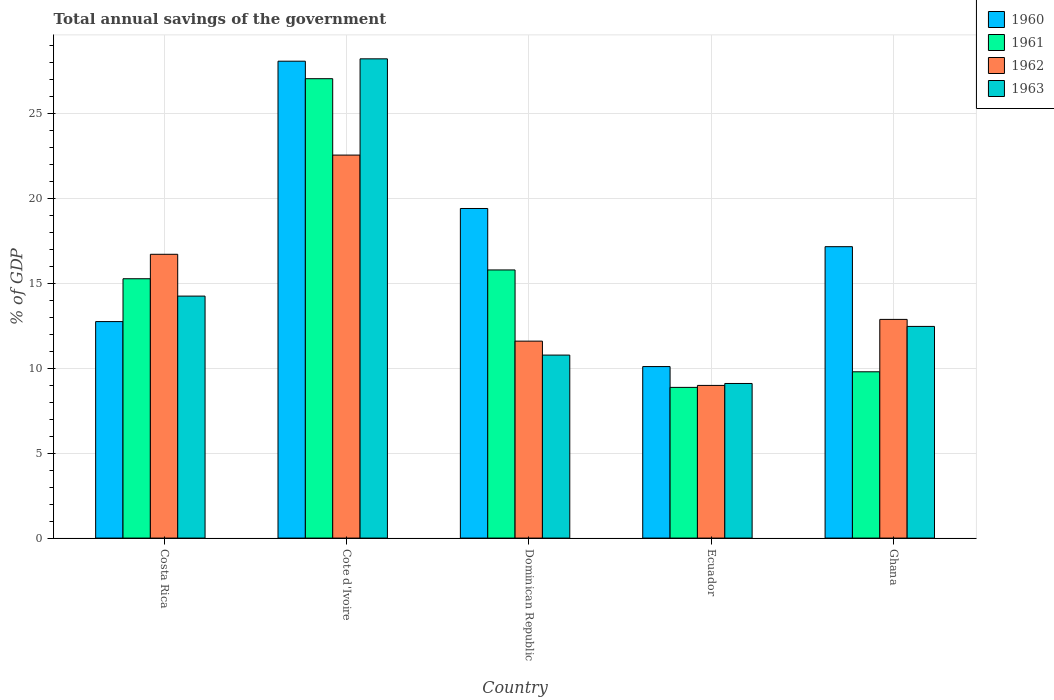How many different coloured bars are there?
Keep it short and to the point. 4. How many groups of bars are there?
Your answer should be very brief. 5. Are the number of bars per tick equal to the number of legend labels?
Ensure brevity in your answer.  Yes. Are the number of bars on each tick of the X-axis equal?
Give a very brief answer. Yes. How many bars are there on the 4th tick from the left?
Provide a succinct answer. 4. What is the total annual savings of the government in 1960 in Cote d'Ivoire?
Keep it short and to the point. 28.06. Across all countries, what is the maximum total annual savings of the government in 1963?
Ensure brevity in your answer.  28.2. Across all countries, what is the minimum total annual savings of the government in 1960?
Offer a very short reply. 10.09. In which country was the total annual savings of the government in 1961 maximum?
Provide a short and direct response. Cote d'Ivoire. In which country was the total annual savings of the government in 1963 minimum?
Give a very brief answer. Ecuador. What is the total total annual savings of the government in 1963 in the graph?
Offer a terse response. 74.76. What is the difference between the total annual savings of the government in 1960 in Cote d'Ivoire and that in Ecuador?
Provide a succinct answer. 17.97. What is the difference between the total annual savings of the government in 1962 in Costa Rica and the total annual savings of the government in 1963 in Ecuador?
Your response must be concise. 7.6. What is the average total annual savings of the government in 1960 per country?
Keep it short and to the point. 17.49. What is the difference between the total annual savings of the government of/in 1961 and total annual savings of the government of/in 1963 in Cote d'Ivoire?
Your answer should be compact. -1.17. In how many countries, is the total annual savings of the government in 1960 greater than 23 %?
Your answer should be very brief. 1. What is the ratio of the total annual savings of the government in 1962 in Cote d'Ivoire to that in Dominican Republic?
Make the answer very short. 1.94. Is the total annual savings of the government in 1963 in Dominican Republic less than that in Ghana?
Make the answer very short. Yes. What is the difference between the highest and the second highest total annual savings of the government in 1962?
Your answer should be very brief. 3.83. What is the difference between the highest and the lowest total annual savings of the government in 1961?
Provide a short and direct response. 18.16. Is the sum of the total annual savings of the government in 1960 in Dominican Republic and Ghana greater than the maximum total annual savings of the government in 1963 across all countries?
Give a very brief answer. Yes. What does the 2nd bar from the left in Ecuador represents?
Make the answer very short. 1961. What does the 1st bar from the right in Ghana represents?
Offer a very short reply. 1963. Is it the case that in every country, the sum of the total annual savings of the government in 1960 and total annual savings of the government in 1962 is greater than the total annual savings of the government in 1961?
Keep it short and to the point. Yes. How many bars are there?
Give a very brief answer. 20. Does the graph contain grids?
Your answer should be compact. Yes. Where does the legend appear in the graph?
Your answer should be compact. Top right. How many legend labels are there?
Ensure brevity in your answer.  4. How are the legend labels stacked?
Provide a succinct answer. Vertical. What is the title of the graph?
Make the answer very short. Total annual savings of the government. Does "1976" appear as one of the legend labels in the graph?
Your answer should be compact. No. What is the label or title of the Y-axis?
Provide a succinct answer. % of GDP. What is the % of GDP in 1960 in Costa Rica?
Make the answer very short. 12.74. What is the % of GDP in 1961 in Costa Rica?
Keep it short and to the point. 15.26. What is the % of GDP of 1962 in Costa Rica?
Make the answer very short. 16.7. What is the % of GDP in 1963 in Costa Rica?
Make the answer very short. 14.24. What is the % of GDP of 1960 in Cote d'Ivoire?
Keep it short and to the point. 28.06. What is the % of GDP in 1961 in Cote d'Ivoire?
Provide a short and direct response. 27.03. What is the % of GDP of 1962 in Cote d'Ivoire?
Offer a very short reply. 22.54. What is the % of GDP in 1963 in Cote d'Ivoire?
Give a very brief answer. 28.2. What is the % of GDP in 1960 in Dominican Republic?
Your response must be concise. 19.39. What is the % of GDP in 1961 in Dominican Republic?
Keep it short and to the point. 15.78. What is the % of GDP in 1962 in Dominican Republic?
Make the answer very short. 11.59. What is the % of GDP of 1963 in Dominican Republic?
Ensure brevity in your answer.  10.77. What is the % of GDP of 1960 in Ecuador?
Ensure brevity in your answer.  10.09. What is the % of GDP of 1961 in Ecuador?
Provide a short and direct response. 8.87. What is the % of GDP in 1962 in Ecuador?
Your answer should be compact. 8.98. What is the % of GDP of 1963 in Ecuador?
Provide a succinct answer. 9.1. What is the % of GDP of 1960 in Ghana?
Keep it short and to the point. 17.15. What is the % of GDP in 1961 in Ghana?
Your response must be concise. 9.78. What is the % of GDP in 1962 in Ghana?
Make the answer very short. 12.87. What is the % of GDP in 1963 in Ghana?
Your answer should be very brief. 12.45. Across all countries, what is the maximum % of GDP of 1960?
Your answer should be compact. 28.06. Across all countries, what is the maximum % of GDP in 1961?
Offer a terse response. 27.03. Across all countries, what is the maximum % of GDP of 1962?
Your response must be concise. 22.54. Across all countries, what is the maximum % of GDP in 1963?
Provide a short and direct response. 28.2. Across all countries, what is the minimum % of GDP of 1960?
Your answer should be very brief. 10.09. Across all countries, what is the minimum % of GDP in 1961?
Keep it short and to the point. 8.87. Across all countries, what is the minimum % of GDP in 1962?
Give a very brief answer. 8.98. Across all countries, what is the minimum % of GDP in 1963?
Your answer should be very brief. 9.1. What is the total % of GDP of 1960 in the graph?
Ensure brevity in your answer.  87.43. What is the total % of GDP of 1961 in the graph?
Give a very brief answer. 76.72. What is the total % of GDP of 1962 in the graph?
Make the answer very short. 72.67. What is the total % of GDP in 1963 in the graph?
Keep it short and to the point. 74.76. What is the difference between the % of GDP of 1960 in Costa Rica and that in Cote d'Ivoire?
Provide a short and direct response. -15.32. What is the difference between the % of GDP of 1961 in Costa Rica and that in Cote d'Ivoire?
Your answer should be compact. -11.77. What is the difference between the % of GDP in 1962 in Costa Rica and that in Cote d'Ivoire?
Your answer should be compact. -5.84. What is the difference between the % of GDP of 1963 in Costa Rica and that in Cote d'Ivoire?
Ensure brevity in your answer.  -13.96. What is the difference between the % of GDP in 1960 in Costa Rica and that in Dominican Republic?
Provide a succinct answer. -6.65. What is the difference between the % of GDP of 1961 in Costa Rica and that in Dominican Republic?
Ensure brevity in your answer.  -0.52. What is the difference between the % of GDP in 1962 in Costa Rica and that in Dominican Republic?
Your response must be concise. 5.11. What is the difference between the % of GDP of 1963 in Costa Rica and that in Dominican Republic?
Make the answer very short. 3.47. What is the difference between the % of GDP in 1960 in Costa Rica and that in Ecuador?
Offer a very short reply. 2.65. What is the difference between the % of GDP of 1961 in Costa Rica and that in Ecuador?
Give a very brief answer. 6.39. What is the difference between the % of GDP of 1962 in Costa Rica and that in Ecuador?
Give a very brief answer. 7.71. What is the difference between the % of GDP of 1963 in Costa Rica and that in Ecuador?
Provide a succinct answer. 5.14. What is the difference between the % of GDP of 1960 in Costa Rica and that in Ghana?
Offer a very short reply. -4.41. What is the difference between the % of GDP in 1961 in Costa Rica and that in Ghana?
Make the answer very short. 5.47. What is the difference between the % of GDP of 1962 in Costa Rica and that in Ghana?
Your response must be concise. 3.83. What is the difference between the % of GDP in 1963 in Costa Rica and that in Ghana?
Your response must be concise. 1.78. What is the difference between the % of GDP of 1960 in Cote d'Ivoire and that in Dominican Republic?
Provide a succinct answer. 8.67. What is the difference between the % of GDP of 1961 in Cote d'Ivoire and that in Dominican Republic?
Offer a terse response. 11.25. What is the difference between the % of GDP of 1962 in Cote d'Ivoire and that in Dominican Republic?
Your answer should be compact. 10.95. What is the difference between the % of GDP in 1963 in Cote d'Ivoire and that in Dominican Republic?
Your response must be concise. 17.43. What is the difference between the % of GDP in 1960 in Cote d'Ivoire and that in Ecuador?
Make the answer very short. 17.97. What is the difference between the % of GDP in 1961 in Cote d'Ivoire and that in Ecuador?
Keep it short and to the point. 18.16. What is the difference between the % of GDP in 1962 in Cote d'Ivoire and that in Ecuador?
Make the answer very short. 13.55. What is the difference between the % of GDP of 1963 in Cote d'Ivoire and that in Ecuador?
Provide a short and direct response. 19.1. What is the difference between the % of GDP in 1960 in Cote d'Ivoire and that in Ghana?
Keep it short and to the point. 10.91. What is the difference between the % of GDP of 1961 in Cote d'Ivoire and that in Ghana?
Provide a short and direct response. 17.25. What is the difference between the % of GDP of 1962 in Cote d'Ivoire and that in Ghana?
Your answer should be compact. 9.67. What is the difference between the % of GDP of 1963 in Cote d'Ivoire and that in Ghana?
Provide a short and direct response. 15.74. What is the difference between the % of GDP of 1960 in Dominican Republic and that in Ecuador?
Offer a very short reply. 9.3. What is the difference between the % of GDP in 1961 in Dominican Republic and that in Ecuador?
Keep it short and to the point. 6.91. What is the difference between the % of GDP in 1962 in Dominican Republic and that in Ecuador?
Your answer should be compact. 2.61. What is the difference between the % of GDP of 1963 in Dominican Republic and that in Ecuador?
Offer a very short reply. 1.67. What is the difference between the % of GDP in 1960 in Dominican Republic and that in Ghana?
Make the answer very short. 2.25. What is the difference between the % of GDP in 1961 in Dominican Republic and that in Ghana?
Make the answer very short. 5.99. What is the difference between the % of GDP in 1962 in Dominican Republic and that in Ghana?
Your answer should be very brief. -1.28. What is the difference between the % of GDP of 1963 in Dominican Republic and that in Ghana?
Keep it short and to the point. -1.69. What is the difference between the % of GDP of 1960 in Ecuador and that in Ghana?
Ensure brevity in your answer.  -7.05. What is the difference between the % of GDP in 1961 in Ecuador and that in Ghana?
Provide a succinct answer. -0.92. What is the difference between the % of GDP of 1962 in Ecuador and that in Ghana?
Provide a short and direct response. -3.88. What is the difference between the % of GDP of 1963 in Ecuador and that in Ghana?
Give a very brief answer. -3.36. What is the difference between the % of GDP in 1960 in Costa Rica and the % of GDP in 1961 in Cote d'Ivoire?
Keep it short and to the point. -14.29. What is the difference between the % of GDP of 1960 in Costa Rica and the % of GDP of 1962 in Cote d'Ivoire?
Provide a short and direct response. -9.8. What is the difference between the % of GDP of 1960 in Costa Rica and the % of GDP of 1963 in Cote d'Ivoire?
Your response must be concise. -15.46. What is the difference between the % of GDP in 1961 in Costa Rica and the % of GDP in 1962 in Cote d'Ivoire?
Provide a short and direct response. -7.28. What is the difference between the % of GDP in 1961 in Costa Rica and the % of GDP in 1963 in Cote d'Ivoire?
Your answer should be compact. -12.94. What is the difference between the % of GDP in 1962 in Costa Rica and the % of GDP in 1963 in Cote d'Ivoire?
Provide a succinct answer. -11.5. What is the difference between the % of GDP in 1960 in Costa Rica and the % of GDP in 1961 in Dominican Republic?
Provide a short and direct response. -3.04. What is the difference between the % of GDP in 1960 in Costa Rica and the % of GDP in 1962 in Dominican Republic?
Offer a terse response. 1.15. What is the difference between the % of GDP of 1960 in Costa Rica and the % of GDP of 1963 in Dominican Republic?
Give a very brief answer. 1.97. What is the difference between the % of GDP in 1961 in Costa Rica and the % of GDP in 1962 in Dominican Republic?
Ensure brevity in your answer.  3.67. What is the difference between the % of GDP of 1961 in Costa Rica and the % of GDP of 1963 in Dominican Republic?
Your answer should be very brief. 4.49. What is the difference between the % of GDP in 1962 in Costa Rica and the % of GDP in 1963 in Dominican Republic?
Your answer should be very brief. 5.93. What is the difference between the % of GDP in 1960 in Costa Rica and the % of GDP in 1961 in Ecuador?
Ensure brevity in your answer.  3.87. What is the difference between the % of GDP of 1960 in Costa Rica and the % of GDP of 1962 in Ecuador?
Your answer should be compact. 3.76. What is the difference between the % of GDP of 1960 in Costa Rica and the % of GDP of 1963 in Ecuador?
Offer a terse response. 3.64. What is the difference between the % of GDP of 1961 in Costa Rica and the % of GDP of 1962 in Ecuador?
Ensure brevity in your answer.  6.28. What is the difference between the % of GDP of 1961 in Costa Rica and the % of GDP of 1963 in Ecuador?
Give a very brief answer. 6.16. What is the difference between the % of GDP in 1962 in Costa Rica and the % of GDP in 1963 in Ecuador?
Provide a succinct answer. 7.6. What is the difference between the % of GDP of 1960 in Costa Rica and the % of GDP of 1961 in Ghana?
Offer a terse response. 2.95. What is the difference between the % of GDP of 1960 in Costa Rica and the % of GDP of 1962 in Ghana?
Provide a succinct answer. -0.13. What is the difference between the % of GDP of 1960 in Costa Rica and the % of GDP of 1963 in Ghana?
Provide a succinct answer. 0.28. What is the difference between the % of GDP of 1961 in Costa Rica and the % of GDP of 1962 in Ghana?
Offer a terse response. 2.39. What is the difference between the % of GDP in 1961 in Costa Rica and the % of GDP in 1963 in Ghana?
Offer a terse response. 2.81. What is the difference between the % of GDP of 1962 in Costa Rica and the % of GDP of 1963 in Ghana?
Provide a succinct answer. 4.24. What is the difference between the % of GDP of 1960 in Cote d'Ivoire and the % of GDP of 1961 in Dominican Republic?
Keep it short and to the point. 12.28. What is the difference between the % of GDP in 1960 in Cote d'Ivoire and the % of GDP in 1962 in Dominican Republic?
Give a very brief answer. 16.47. What is the difference between the % of GDP in 1960 in Cote d'Ivoire and the % of GDP in 1963 in Dominican Republic?
Offer a very short reply. 17.29. What is the difference between the % of GDP in 1961 in Cote d'Ivoire and the % of GDP in 1962 in Dominican Republic?
Your answer should be compact. 15.44. What is the difference between the % of GDP in 1961 in Cote d'Ivoire and the % of GDP in 1963 in Dominican Republic?
Provide a short and direct response. 16.26. What is the difference between the % of GDP in 1962 in Cote d'Ivoire and the % of GDP in 1963 in Dominican Republic?
Your answer should be very brief. 11.77. What is the difference between the % of GDP in 1960 in Cote d'Ivoire and the % of GDP in 1961 in Ecuador?
Your answer should be very brief. 19.19. What is the difference between the % of GDP in 1960 in Cote d'Ivoire and the % of GDP in 1962 in Ecuador?
Provide a short and direct response. 19.08. What is the difference between the % of GDP in 1960 in Cote d'Ivoire and the % of GDP in 1963 in Ecuador?
Give a very brief answer. 18.96. What is the difference between the % of GDP of 1961 in Cote d'Ivoire and the % of GDP of 1962 in Ecuador?
Provide a short and direct response. 18.05. What is the difference between the % of GDP in 1961 in Cote d'Ivoire and the % of GDP in 1963 in Ecuador?
Offer a terse response. 17.93. What is the difference between the % of GDP of 1962 in Cote d'Ivoire and the % of GDP of 1963 in Ecuador?
Give a very brief answer. 13.44. What is the difference between the % of GDP in 1960 in Cote d'Ivoire and the % of GDP in 1961 in Ghana?
Your answer should be very brief. 18.27. What is the difference between the % of GDP of 1960 in Cote d'Ivoire and the % of GDP of 1962 in Ghana?
Your answer should be very brief. 15.19. What is the difference between the % of GDP in 1960 in Cote d'Ivoire and the % of GDP in 1963 in Ghana?
Give a very brief answer. 15.61. What is the difference between the % of GDP in 1961 in Cote d'Ivoire and the % of GDP in 1962 in Ghana?
Give a very brief answer. 14.16. What is the difference between the % of GDP in 1961 in Cote d'Ivoire and the % of GDP in 1963 in Ghana?
Provide a succinct answer. 14.58. What is the difference between the % of GDP of 1962 in Cote d'Ivoire and the % of GDP of 1963 in Ghana?
Give a very brief answer. 10.08. What is the difference between the % of GDP of 1960 in Dominican Republic and the % of GDP of 1961 in Ecuador?
Offer a very short reply. 10.53. What is the difference between the % of GDP of 1960 in Dominican Republic and the % of GDP of 1962 in Ecuador?
Ensure brevity in your answer.  10.41. What is the difference between the % of GDP in 1960 in Dominican Republic and the % of GDP in 1963 in Ecuador?
Your answer should be very brief. 10.3. What is the difference between the % of GDP in 1961 in Dominican Republic and the % of GDP in 1962 in Ecuador?
Ensure brevity in your answer.  6.79. What is the difference between the % of GDP in 1961 in Dominican Republic and the % of GDP in 1963 in Ecuador?
Offer a terse response. 6.68. What is the difference between the % of GDP in 1962 in Dominican Republic and the % of GDP in 1963 in Ecuador?
Offer a terse response. 2.49. What is the difference between the % of GDP of 1960 in Dominican Republic and the % of GDP of 1961 in Ghana?
Give a very brief answer. 9.61. What is the difference between the % of GDP in 1960 in Dominican Republic and the % of GDP in 1962 in Ghana?
Give a very brief answer. 6.53. What is the difference between the % of GDP in 1960 in Dominican Republic and the % of GDP in 1963 in Ghana?
Your answer should be very brief. 6.94. What is the difference between the % of GDP in 1961 in Dominican Republic and the % of GDP in 1962 in Ghana?
Make the answer very short. 2.91. What is the difference between the % of GDP in 1961 in Dominican Republic and the % of GDP in 1963 in Ghana?
Your response must be concise. 3.32. What is the difference between the % of GDP of 1962 in Dominican Republic and the % of GDP of 1963 in Ghana?
Offer a very short reply. -0.87. What is the difference between the % of GDP in 1960 in Ecuador and the % of GDP in 1961 in Ghana?
Give a very brief answer. 0.31. What is the difference between the % of GDP of 1960 in Ecuador and the % of GDP of 1962 in Ghana?
Make the answer very short. -2.77. What is the difference between the % of GDP of 1960 in Ecuador and the % of GDP of 1963 in Ghana?
Provide a succinct answer. -2.36. What is the difference between the % of GDP of 1961 in Ecuador and the % of GDP of 1962 in Ghana?
Keep it short and to the point. -4. What is the difference between the % of GDP of 1961 in Ecuador and the % of GDP of 1963 in Ghana?
Your response must be concise. -3.59. What is the difference between the % of GDP of 1962 in Ecuador and the % of GDP of 1963 in Ghana?
Provide a short and direct response. -3.47. What is the average % of GDP in 1960 per country?
Offer a very short reply. 17.49. What is the average % of GDP of 1961 per country?
Make the answer very short. 15.34. What is the average % of GDP in 1962 per country?
Keep it short and to the point. 14.53. What is the average % of GDP in 1963 per country?
Offer a terse response. 14.95. What is the difference between the % of GDP in 1960 and % of GDP in 1961 in Costa Rica?
Offer a very short reply. -2.52. What is the difference between the % of GDP in 1960 and % of GDP in 1962 in Costa Rica?
Provide a succinct answer. -3.96. What is the difference between the % of GDP of 1960 and % of GDP of 1963 in Costa Rica?
Your response must be concise. -1.5. What is the difference between the % of GDP of 1961 and % of GDP of 1962 in Costa Rica?
Your answer should be compact. -1.44. What is the difference between the % of GDP of 1961 and % of GDP of 1963 in Costa Rica?
Give a very brief answer. 1.02. What is the difference between the % of GDP in 1962 and % of GDP in 1963 in Costa Rica?
Make the answer very short. 2.46. What is the difference between the % of GDP of 1960 and % of GDP of 1962 in Cote d'Ivoire?
Offer a very short reply. 5.52. What is the difference between the % of GDP in 1960 and % of GDP in 1963 in Cote d'Ivoire?
Provide a short and direct response. -0.14. What is the difference between the % of GDP in 1961 and % of GDP in 1962 in Cote d'Ivoire?
Your answer should be compact. 4.49. What is the difference between the % of GDP in 1961 and % of GDP in 1963 in Cote d'Ivoire?
Ensure brevity in your answer.  -1.17. What is the difference between the % of GDP in 1962 and % of GDP in 1963 in Cote d'Ivoire?
Make the answer very short. -5.66. What is the difference between the % of GDP in 1960 and % of GDP in 1961 in Dominican Republic?
Your answer should be very brief. 3.62. What is the difference between the % of GDP of 1960 and % of GDP of 1962 in Dominican Republic?
Your answer should be compact. 7.8. What is the difference between the % of GDP in 1960 and % of GDP in 1963 in Dominican Republic?
Give a very brief answer. 8.63. What is the difference between the % of GDP in 1961 and % of GDP in 1962 in Dominican Republic?
Provide a short and direct response. 4.19. What is the difference between the % of GDP in 1961 and % of GDP in 1963 in Dominican Republic?
Keep it short and to the point. 5.01. What is the difference between the % of GDP of 1962 and % of GDP of 1963 in Dominican Republic?
Offer a very short reply. 0.82. What is the difference between the % of GDP of 1960 and % of GDP of 1961 in Ecuador?
Offer a very short reply. 1.22. What is the difference between the % of GDP of 1960 and % of GDP of 1962 in Ecuador?
Keep it short and to the point. 1.11. What is the difference between the % of GDP in 1961 and % of GDP in 1962 in Ecuador?
Provide a short and direct response. -0.12. What is the difference between the % of GDP of 1961 and % of GDP of 1963 in Ecuador?
Offer a very short reply. -0.23. What is the difference between the % of GDP in 1962 and % of GDP in 1963 in Ecuador?
Give a very brief answer. -0.11. What is the difference between the % of GDP in 1960 and % of GDP in 1961 in Ghana?
Make the answer very short. 7.36. What is the difference between the % of GDP in 1960 and % of GDP in 1962 in Ghana?
Provide a short and direct response. 4.28. What is the difference between the % of GDP in 1960 and % of GDP in 1963 in Ghana?
Your answer should be very brief. 4.69. What is the difference between the % of GDP of 1961 and % of GDP of 1962 in Ghana?
Your response must be concise. -3.08. What is the difference between the % of GDP in 1961 and % of GDP in 1963 in Ghana?
Offer a terse response. -2.67. What is the difference between the % of GDP in 1962 and % of GDP in 1963 in Ghana?
Keep it short and to the point. 0.41. What is the ratio of the % of GDP of 1960 in Costa Rica to that in Cote d'Ivoire?
Your response must be concise. 0.45. What is the ratio of the % of GDP of 1961 in Costa Rica to that in Cote d'Ivoire?
Your answer should be compact. 0.56. What is the ratio of the % of GDP of 1962 in Costa Rica to that in Cote d'Ivoire?
Give a very brief answer. 0.74. What is the ratio of the % of GDP in 1963 in Costa Rica to that in Cote d'Ivoire?
Your answer should be very brief. 0.5. What is the ratio of the % of GDP in 1960 in Costa Rica to that in Dominican Republic?
Your response must be concise. 0.66. What is the ratio of the % of GDP of 1961 in Costa Rica to that in Dominican Republic?
Provide a short and direct response. 0.97. What is the ratio of the % of GDP of 1962 in Costa Rica to that in Dominican Republic?
Provide a succinct answer. 1.44. What is the ratio of the % of GDP of 1963 in Costa Rica to that in Dominican Republic?
Your answer should be compact. 1.32. What is the ratio of the % of GDP in 1960 in Costa Rica to that in Ecuador?
Make the answer very short. 1.26. What is the ratio of the % of GDP of 1961 in Costa Rica to that in Ecuador?
Your answer should be compact. 1.72. What is the ratio of the % of GDP of 1962 in Costa Rica to that in Ecuador?
Ensure brevity in your answer.  1.86. What is the ratio of the % of GDP in 1963 in Costa Rica to that in Ecuador?
Give a very brief answer. 1.57. What is the ratio of the % of GDP in 1960 in Costa Rica to that in Ghana?
Ensure brevity in your answer.  0.74. What is the ratio of the % of GDP of 1961 in Costa Rica to that in Ghana?
Your answer should be compact. 1.56. What is the ratio of the % of GDP in 1962 in Costa Rica to that in Ghana?
Provide a short and direct response. 1.3. What is the ratio of the % of GDP in 1963 in Costa Rica to that in Ghana?
Ensure brevity in your answer.  1.14. What is the ratio of the % of GDP in 1960 in Cote d'Ivoire to that in Dominican Republic?
Provide a succinct answer. 1.45. What is the ratio of the % of GDP of 1961 in Cote d'Ivoire to that in Dominican Republic?
Ensure brevity in your answer.  1.71. What is the ratio of the % of GDP in 1962 in Cote d'Ivoire to that in Dominican Republic?
Your answer should be compact. 1.94. What is the ratio of the % of GDP in 1963 in Cote d'Ivoire to that in Dominican Republic?
Offer a very short reply. 2.62. What is the ratio of the % of GDP in 1960 in Cote d'Ivoire to that in Ecuador?
Your answer should be compact. 2.78. What is the ratio of the % of GDP in 1961 in Cote d'Ivoire to that in Ecuador?
Keep it short and to the point. 3.05. What is the ratio of the % of GDP of 1962 in Cote d'Ivoire to that in Ecuador?
Offer a very short reply. 2.51. What is the ratio of the % of GDP in 1963 in Cote d'Ivoire to that in Ecuador?
Provide a succinct answer. 3.1. What is the ratio of the % of GDP in 1960 in Cote d'Ivoire to that in Ghana?
Provide a short and direct response. 1.64. What is the ratio of the % of GDP of 1961 in Cote d'Ivoire to that in Ghana?
Provide a short and direct response. 2.76. What is the ratio of the % of GDP in 1962 in Cote d'Ivoire to that in Ghana?
Provide a succinct answer. 1.75. What is the ratio of the % of GDP of 1963 in Cote d'Ivoire to that in Ghana?
Give a very brief answer. 2.26. What is the ratio of the % of GDP of 1960 in Dominican Republic to that in Ecuador?
Your answer should be compact. 1.92. What is the ratio of the % of GDP in 1961 in Dominican Republic to that in Ecuador?
Keep it short and to the point. 1.78. What is the ratio of the % of GDP in 1962 in Dominican Republic to that in Ecuador?
Make the answer very short. 1.29. What is the ratio of the % of GDP of 1963 in Dominican Republic to that in Ecuador?
Give a very brief answer. 1.18. What is the ratio of the % of GDP in 1960 in Dominican Republic to that in Ghana?
Give a very brief answer. 1.13. What is the ratio of the % of GDP of 1961 in Dominican Republic to that in Ghana?
Offer a terse response. 1.61. What is the ratio of the % of GDP in 1962 in Dominican Republic to that in Ghana?
Your response must be concise. 0.9. What is the ratio of the % of GDP in 1963 in Dominican Republic to that in Ghana?
Provide a succinct answer. 0.86. What is the ratio of the % of GDP in 1960 in Ecuador to that in Ghana?
Provide a short and direct response. 0.59. What is the ratio of the % of GDP in 1961 in Ecuador to that in Ghana?
Offer a very short reply. 0.91. What is the ratio of the % of GDP in 1962 in Ecuador to that in Ghana?
Your answer should be compact. 0.7. What is the ratio of the % of GDP in 1963 in Ecuador to that in Ghana?
Offer a very short reply. 0.73. What is the difference between the highest and the second highest % of GDP in 1960?
Ensure brevity in your answer.  8.67. What is the difference between the highest and the second highest % of GDP of 1961?
Provide a succinct answer. 11.25. What is the difference between the highest and the second highest % of GDP of 1962?
Your response must be concise. 5.84. What is the difference between the highest and the second highest % of GDP in 1963?
Provide a short and direct response. 13.96. What is the difference between the highest and the lowest % of GDP of 1960?
Make the answer very short. 17.97. What is the difference between the highest and the lowest % of GDP of 1961?
Provide a succinct answer. 18.16. What is the difference between the highest and the lowest % of GDP in 1962?
Give a very brief answer. 13.55. What is the difference between the highest and the lowest % of GDP in 1963?
Your answer should be very brief. 19.1. 